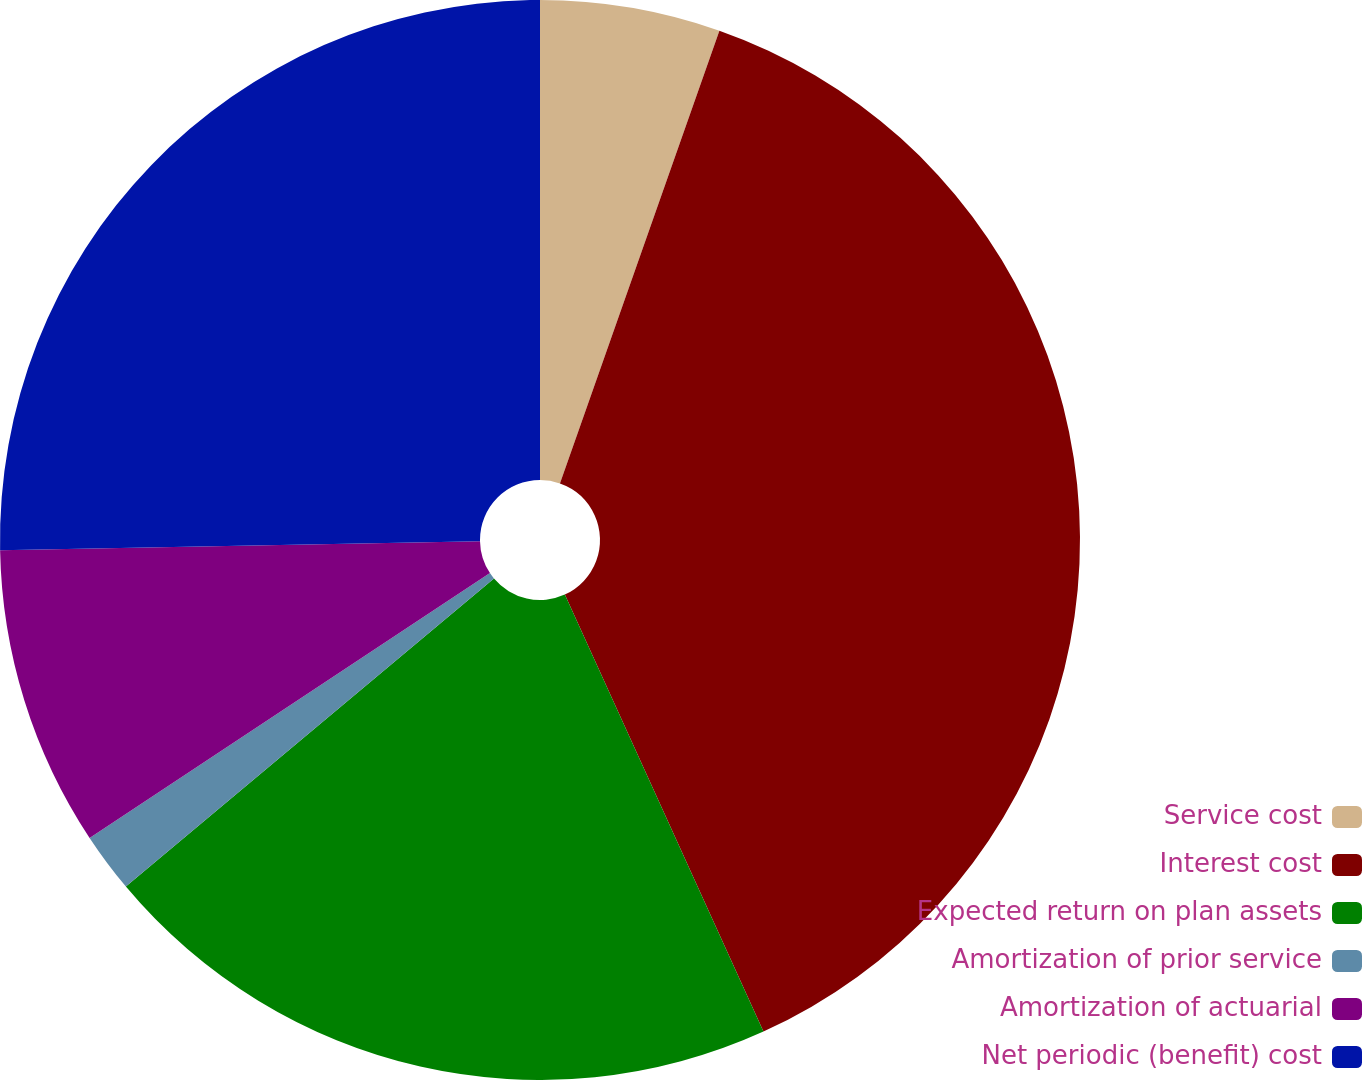Convert chart to OTSL. <chart><loc_0><loc_0><loc_500><loc_500><pie_chart><fcel>Service cost<fcel>Interest cost<fcel>Expected return on plan assets<fcel>Amortization of prior service<fcel>Amortization of actuarial<fcel>Net periodic (benefit) cost<nl><fcel>5.39%<fcel>37.82%<fcel>20.7%<fcel>1.79%<fcel>9.0%<fcel>25.3%<nl></chart> 